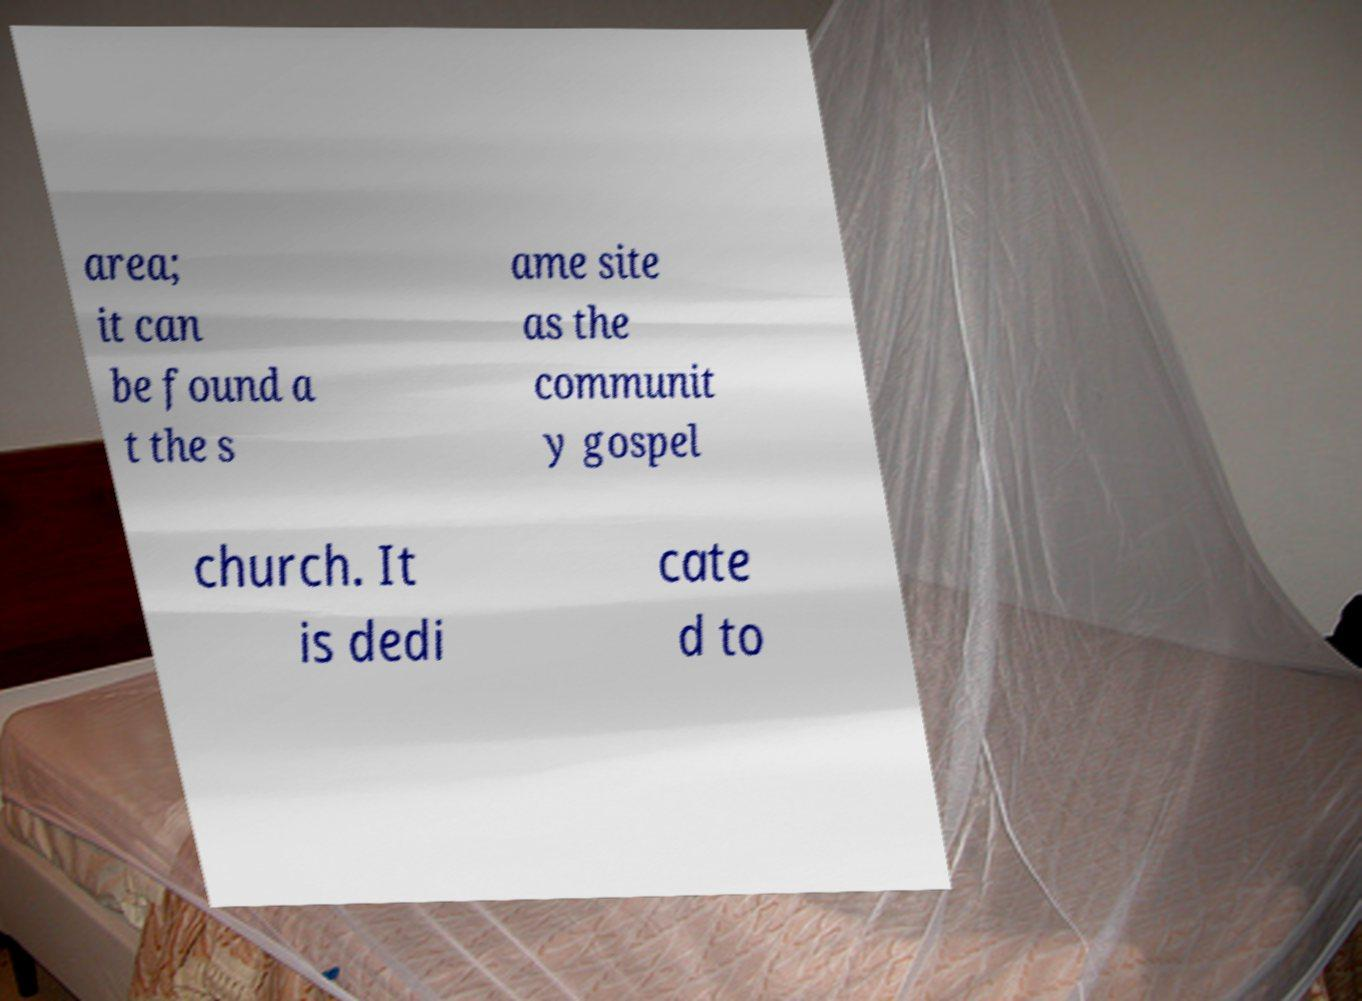Could you extract and type out the text from this image? area; it can be found a t the s ame site as the communit y gospel church. It is dedi cate d to 